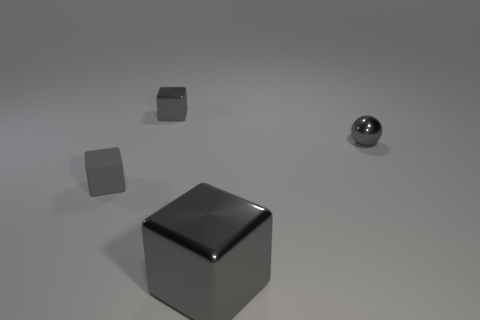What is the color of the tiny thing that is behind the gray shiny sphere?
Offer a terse response. Gray. How many gray things are metallic spheres or cubes?
Give a very brief answer. 4. What color is the big metal block?
Make the answer very short. Gray. Is there any other thing that has the same material as the big gray thing?
Offer a very short reply. Yes. Are there fewer small metal objects that are on the left side of the big gray metallic object than tiny gray cubes that are behind the small gray matte block?
Offer a terse response. No. What is the shape of the object that is in front of the metallic ball and left of the big gray thing?
Make the answer very short. Cube. How many other gray metal objects have the same shape as the big gray metal thing?
Ensure brevity in your answer.  1. What is the size of the gray ball that is made of the same material as the large gray thing?
Make the answer very short. Small. What number of cyan balls are the same size as the gray rubber cube?
Make the answer very short. 0. There is a matte thing that is the same color as the tiny shiny sphere; what is its size?
Ensure brevity in your answer.  Small. 